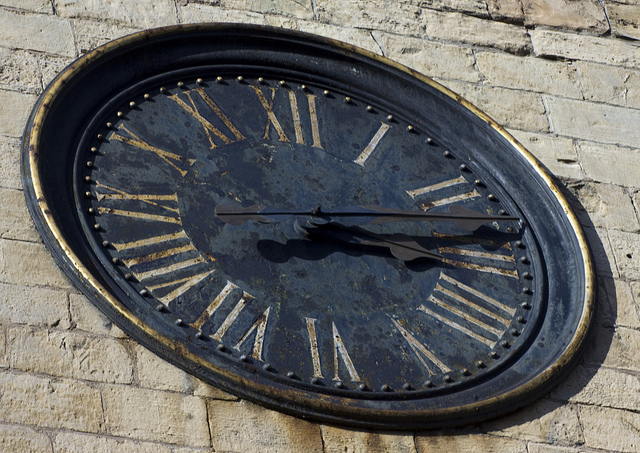What might the history or origin of this clock be? While the specific history is not known from the image alone, the clock's design suggests it could be of European origin, potentially dating back a few centuries. It may have hung on a public building or a tower, serving as a timepiece for the community. The weathering indicates long-term exposure to the elements, hinting at its historical resilience and continued importance. 